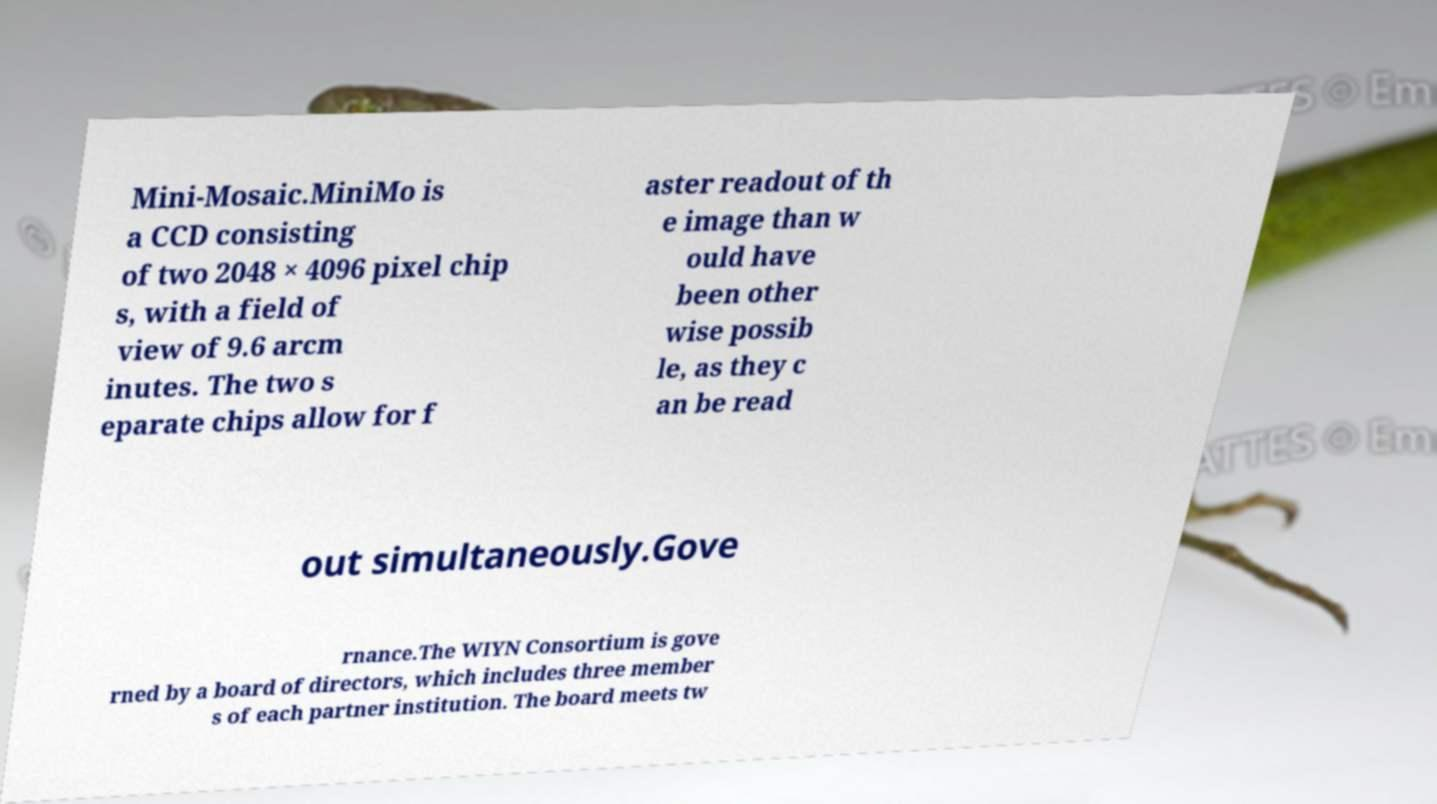Please read and relay the text visible in this image. What does it say? Mini-Mosaic.MiniMo is a CCD consisting of two 2048 × 4096 pixel chip s, with a field of view of 9.6 arcm inutes. The two s eparate chips allow for f aster readout of th e image than w ould have been other wise possib le, as they c an be read out simultaneously.Gove rnance.The WIYN Consortium is gove rned by a board of directors, which includes three member s of each partner institution. The board meets tw 